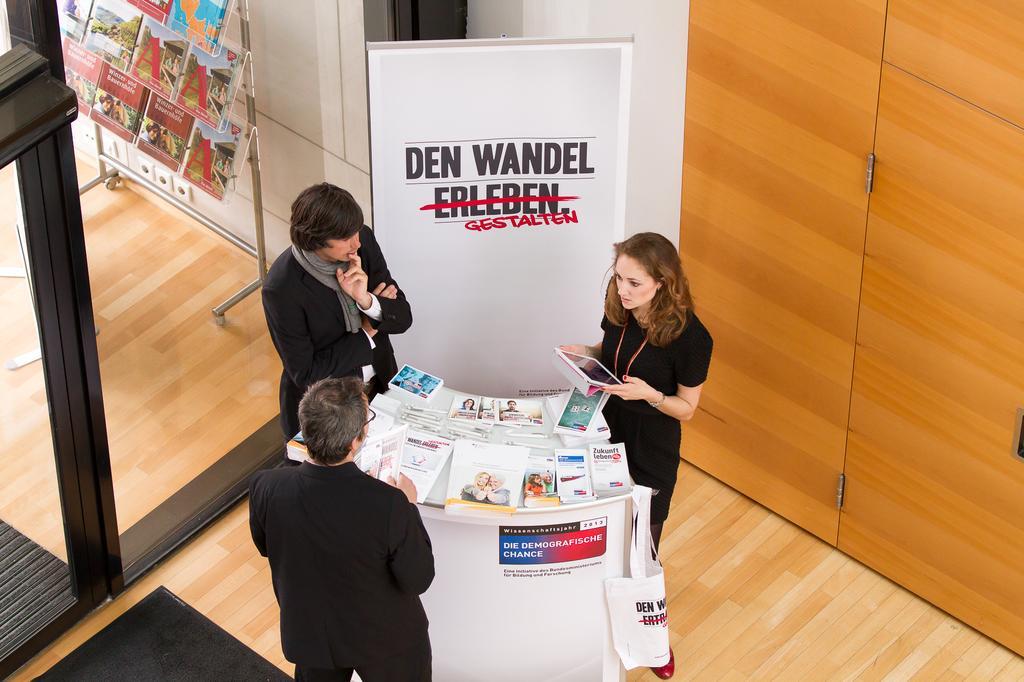Could you give a brief overview of what you see in this image? In this image, we can see people standing and one of them is wearing scarf and we can see a lady wearing an id card and holding a tab and there are books and a bag on the stand. In the background, there is a board, glass door and a wall and through the glass we can see magazines and a stand. At the bottom, there is floor. 